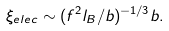<formula> <loc_0><loc_0><loc_500><loc_500>\xi _ { e l e c } \sim ( f ^ { 2 } l _ { B } / b ) ^ { - 1 / 3 } b .</formula> 